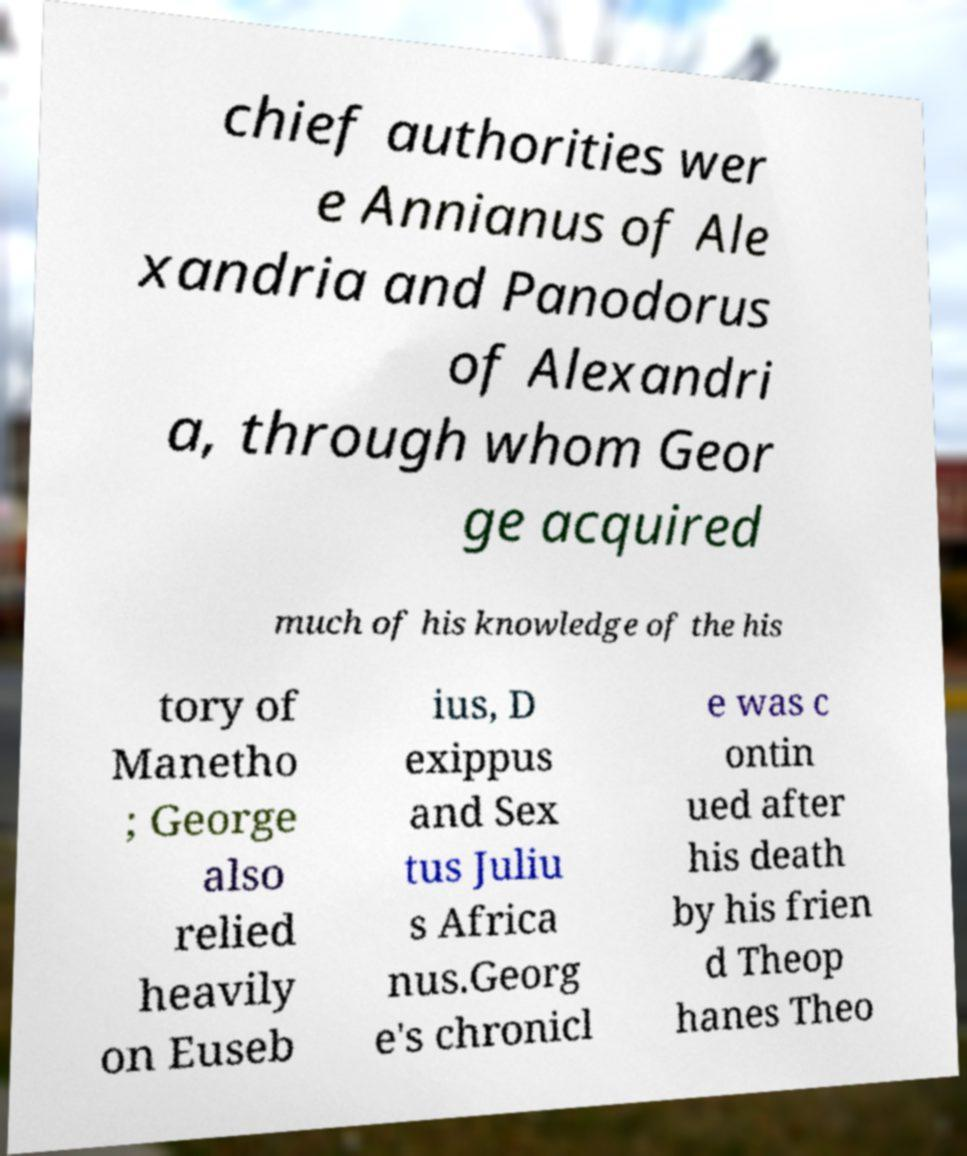Please identify and transcribe the text found in this image. chief authorities wer e Annianus of Ale xandria and Panodorus of Alexandri a, through whom Geor ge acquired much of his knowledge of the his tory of Manetho ; George also relied heavily on Euseb ius, D exippus and Sex tus Juliu s Africa nus.Georg e's chronicl e was c ontin ued after his death by his frien d Theop hanes Theo 